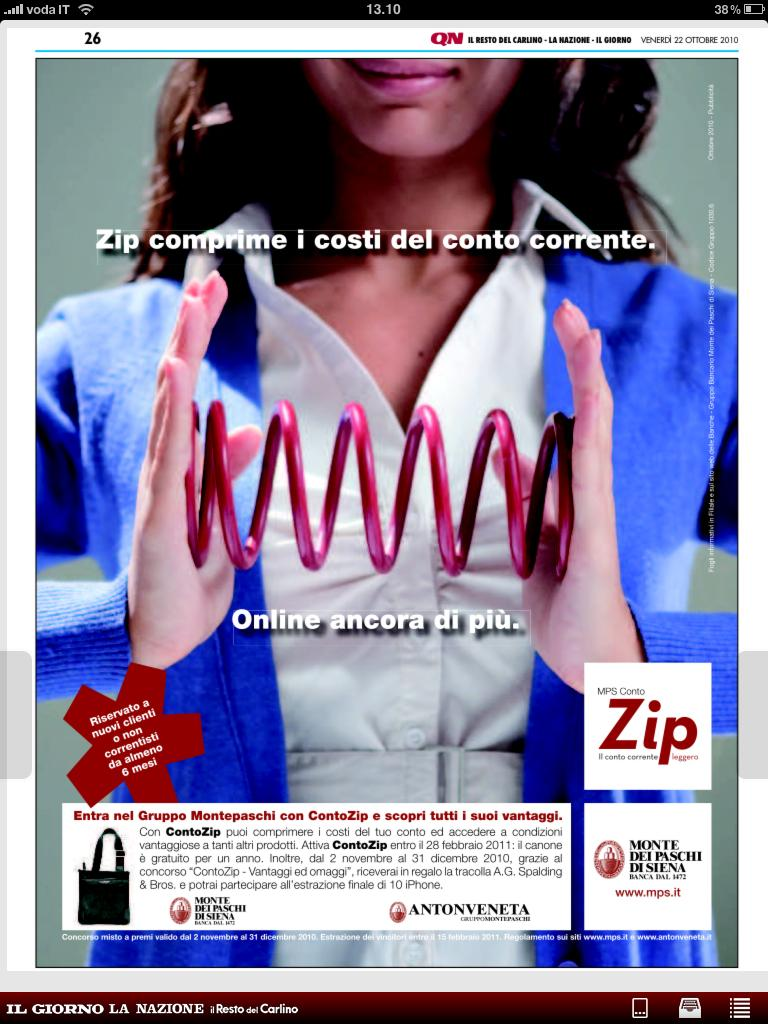What type of image is shown in the screenshot? The image is a screenshot of a screen. What can be seen on the screenshot besides the image of the woman? There is some text visible on the screenshot. What is the woman doing in the image? The woman is holding an object in the image. What is the color of the object being held by the woman? The object being held by the woman is pink in color. Where is the woman giving birth in the image? There is no indication of a woman giving birth in the image; it features a woman holding a pink object. What type of food is being served in the lunchroom in the image? There is no lunchroom or food visible in the image; it only shows a woman holding a pink object. 